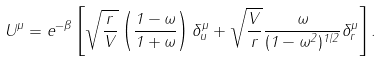<formula> <loc_0><loc_0><loc_500><loc_500>U ^ { \mu } = e ^ { - \beta } \left [ \sqrt { \frac { r } { V } } \left ( \frac { 1 - \omega } { 1 + \omega } \right ) \delta ^ { \mu } _ { u } + \sqrt { \frac { V } { r } } \frac { \omega } { ( 1 - \omega ^ { 2 } ) ^ { 1 / 2 } } \delta ^ { \mu } _ { r } \right ] .</formula> 